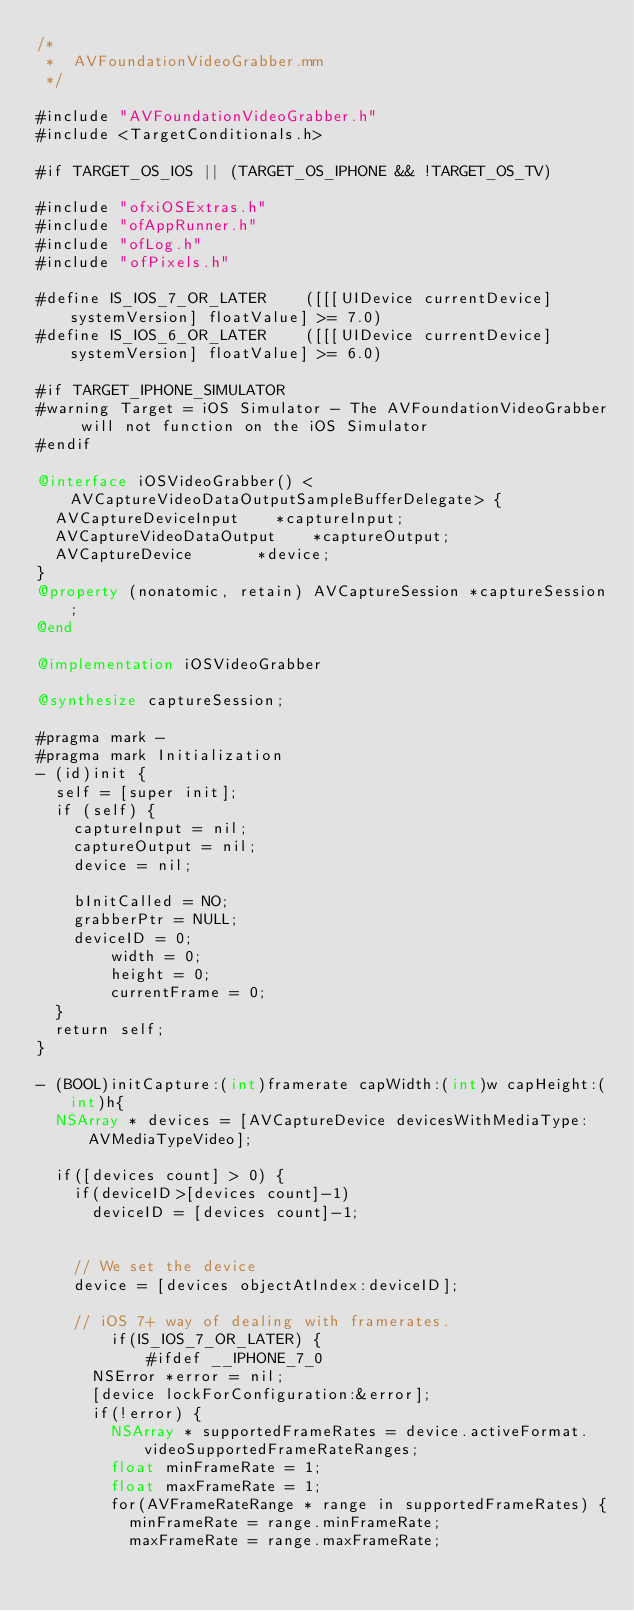<code> <loc_0><loc_0><loc_500><loc_500><_ObjectiveC_>/*
 *  AVFoundationVideoGrabber.mm
 */

#include "AVFoundationVideoGrabber.h"
#include <TargetConditionals.h>

#if TARGET_OS_IOS || (TARGET_OS_IPHONE && !TARGET_OS_TV)

#include "ofxiOSExtras.h"
#include "ofAppRunner.h"
#include "ofLog.h"
#include "ofPixels.h"

#define IS_IOS_7_OR_LATER    ([[[UIDevice currentDevice] systemVersion] floatValue] >= 7.0)
#define IS_IOS_6_OR_LATER    ([[[UIDevice currentDevice] systemVersion] floatValue] >= 6.0)

#if TARGET_IPHONE_SIMULATOR
#warning Target = iOS Simulator - The AVFoundationVideoGrabber will not function on the iOS Simulator
#endif

@interface iOSVideoGrabber() <AVCaptureVideoDataOutputSampleBufferDelegate> {
	AVCaptureDeviceInput		*captureInput;	
	AVCaptureVideoDataOutput    *captureOutput;
	AVCaptureDevice				*device;
}
@property (nonatomic, retain) AVCaptureSession *captureSession;
@end

@implementation iOSVideoGrabber

@synthesize captureSession;

#pragma mark -
#pragma mark Initialization
- (id)init {
	self = [super init];
	if (self) {
		captureInput = nil;
		captureOutput = nil;
		device = nil;

		bInitCalled = NO;
		grabberPtr = NULL;
		deviceID = 0;
        width = 0;
        height = 0;
        currentFrame = 0;
	}
	return self;
}

- (BOOL)initCapture:(int)framerate capWidth:(int)w capHeight:(int)h{
	NSArray * devices = [AVCaptureDevice devicesWithMediaType:AVMediaTypeVideo];
	
	if([devices count] > 0) {
		if(deviceID>[devices count]-1)
			deviceID = [devices count]-1;
		
		
		// We set the device
		device = [devices objectAtIndex:deviceID];
		
		// iOS 7+ way of dealing with framerates.
        if(IS_IOS_7_OR_LATER) {
            #ifdef __IPHONE_7_0
			NSError *error = nil;
			[device lockForConfiguration:&error];
			if(!error) {
				NSArray * supportedFrameRates = device.activeFormat.videoSupportedFrameRateRanges;
				float minFrameRate = 1;
				float maxFrameRate = 1;
				for(AVFrameRateRange * range in supportedFrameRates) {
					minFrameRate = range.minFrameRate;
					maxFrameRate = range.maxFrameRate;</code> 